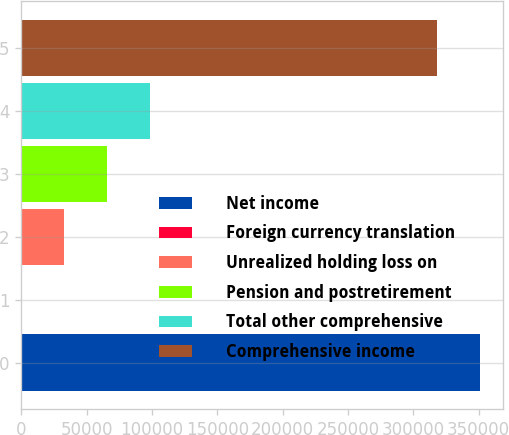Convert chart to OTSL. <chart><loc_0><loc_0><loc_500><loc_500><bar_chart><fcel>Net income<fcel>Foreign currency translation<fcel>Unrealized holding loss on<fcel>Pension and postretirement<fcel>Total other comprehensive<fcel>Comprehensive income<nl><fcel>351182<fcel>15<fcel>32927.7<fcel>65840.4<fcel>98753.1<fcel>318269<nl></chart> 